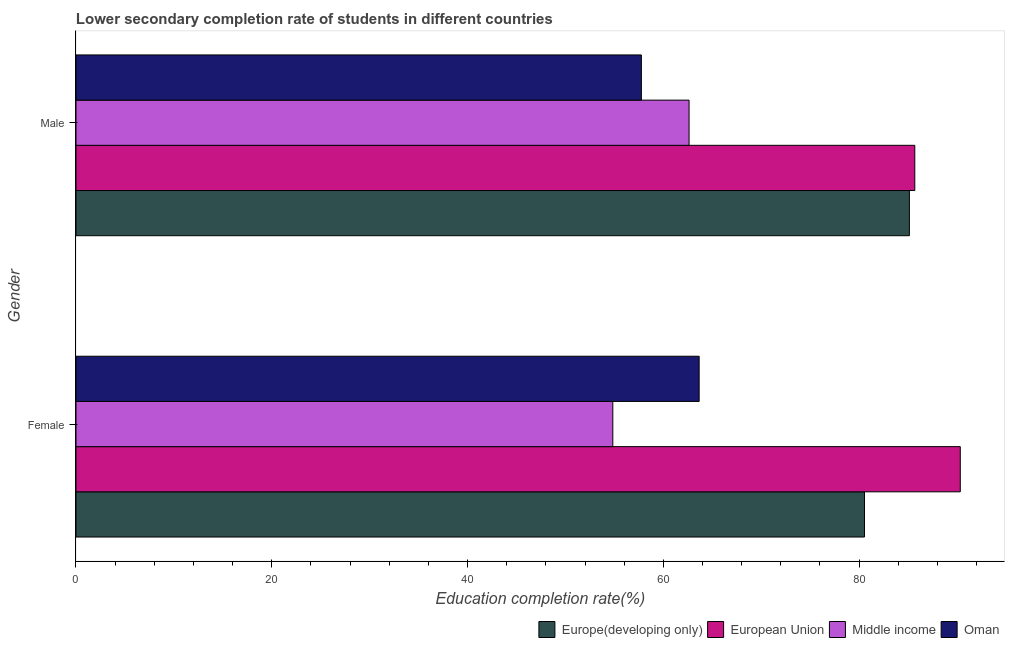How many different coloured bars are there?
Keep it short and to the point. 4. How many groups of bars are there?
Make the answer very short. 2. How many bars are there on the 2nd tick from the bottom?
Provide a succinct answer. 4. What is the label of the 1st group of bars from the top?
Provide a short and direct response. Male. What is the education completion rate of male students in Oman?
Your response must be concise. 57.75. Across all countries, what is the maximum education completion rate of female students?
Provide a short and direct response. 90.33. Across all countries, what is the minimum education completion rate of female students?
Offer a terse response. 54.84. In which country was the education completion rate of male students minimum?
Make the answer very short. Oman. What is the total education completion rate of female students in the graph?
Offer a terse response. 289.37. What is the difference between the education completion rate of female students in European Union and that in Europe(developing only)?
Provide a succinct answer. 9.79. What is the difference between the education completion rate of female students in Middle income and the education completion rate of male students in Oman?
Your answer should be compact. -2.92. What is the average education completion rate of male students per country?
Give a very brief answer. 72.8. What is the difference between the education completion rate of female students and education completion rate of male students in Middle income?
Your answer should be compact. -7.79. In how many countries, is the education completion rate of female students greater than 80 %?
Your answer should be compact. 2. What is the ratio of the education completion rate of female students in Oman to that in Middle income?
Your answer should be very brief. 1.16. What does the 4th bar from the top in Female represents?
Make the answer very short. Europe(developing only). What does the 2nd bar from the bottom in Female represents?
Provide a short and direct response. European Union. How many legend labels are there?
Ensure brevity in your answer.  4. How are the legend labels stacked?
Keep it short and to the point. Horizontal. What is the title of the graph?
Make the answer very short. Lower secondary completion rate of students in different countries. Does "Suriname" appear as one of the legend labels in the graph?
Keep it short and to the point. No. What is the label or title of the X-axis?
Ensure brevity in your answer.  Education completion rate(%). What is the Education completion rate(%) in Europe(developing only) in Female?
Keep it short and to the point. 80.55. What is the Education completion rate(%) of European Union in Female?
Offer a very short reply. 90.33. What is the Education completion rate(%) in Middle income in Female?
Your answer should be compact. 54.84. What is the Education completion rate(%) in Oman in Female?
Offer a terse response. 63.66. What is the Education completion rate(%) of Europe(developing only) in Male?
Offer a very short reply. 85.13. What is the Education completion rate(%) in European Union in Male?
Your answer should be very brief. 85.69. What is the Education completion rate(%) of Middle income in Male?
Provide a short and direct response. 62.63. What is the Education completion rate(%) of Oman in Male?
Give a very brief answer. 57.75. Across all Gender, what is the maximum Education completion rate(%) in Europe(developing only)?
Your answer should be compact. 85.13. Across all Gender, what is the maximum Education completion rate(%) of European Union?
Provide a succinct answer. 90.33. Across all Gender, what is the maximum Education completion rate(%) of Middle income?
Ensure brevity in your answer.  62.63. Across all Gender, what is the maximum Education completion rate(%) in Oman?
Your answer should be compact. 63.66. Across all Gender, what is the minimum Education completion rate(%) in Europe(developing only)?
Offer a terse response. 80.55. Across all Gender, what is the minimum Education completion rate(%) in European Union?
Make the answer very short. 85.69. Across all Gender, what is the minimum Education completion rate(%) of Middle income?
Offer a very short reply. 54.84. Across all Gender, what is the minimum Education completion rate(%) in Oman?
Your answer should be compact. 57.75. What is the total Education completion rate(%) in Europe(developing only) in the graph?
Provide a succinct answer. 165.68. What is the total Education completion rate(%) in European Union in the graph?
Offer a terse response. 176.02. What is the total Education completion rate(%) in Middle income in the graph?
Make the answer very short. 117.47. What is the total Education completion rate(%) of Oman in the graph?
Your answer should be compact. 121.41. What is the difference between the Education completion rate(%) in Europe(developing only) in Female and that in Male?
Give a very brief answer. -4.59. What is the difference between the Education completion rate(%) of European Union in Female and that in Male?
Provide a short and direct response. 4.65. What is the difference between the Education completion rate(%) of Middle income in Female and that in Male?
Ensure brevity in your answer.  -7.79. What is the difference between the Education completion rate(%) in Oman in Female and that in Male?
Your response must be concise. 5.9. What is the difference between the Education completion rate(%) in Europe(developing only) in Female and the Education completion rate(%) in European Union in Male?
Keep it short and to the point. -5.14. What is the difference between the Education completion rate(%) of Europe(developing only) in Female and the Education completion rate(%) of Middle income in Male?
Your response must be concise. 17.92. What is the difference between the Education completion rate(%) in Europe(developing only) in Female and the Education completion rate(%) in Oman in Male?
Give a very brief answer. 22.79. What is the difference between the Education completion rate(%) in European Union in Female and the Education completion rate(%) in Middle income in Male?
Your response must be concise. 27.7. What is the difference between the Education completion rate(%) in European Union in Female and the Education completion rate(%) in Oman in Male?
Make the answer very short. 32.58. What is the difference between the Education completion rate(%) of Middle income in Female and the Education completion rate(%) of Oman in Male?
Provide a succinct answer. -2.92. What is the average Education completion rate(%) of Europe(developing only) per Gender?
Give a very brief answer. 82.84. What is the average Education completion rate(%) of European Union per Gender?
Give a very brief answer. 88.01. What is the average Education completion rate(%) of Middle income per Gender?
Provide a succinct answer. 58.73. What is the average Education completion rate(%) of Oman per Gender?
Provide a short and direct response. 60.71. What is the difference between the Education completion rate(%) of Europe(developing only) and Education completion rate(%) of European Union in Female?
Offer a terse response. -9.79. What is the difference between the Education completion rate(%) of Europe(developing only) and Education completion rate(%) of Middle income in Female?
Ensure brevity in your answer.  25.71. What is the difference between the Education completion rate(%) of Europe(developing only) and Education completion rate(%) of Oman in Female?
Provide a succinct answer. 16.89. What is the difference between the Education completion rate(%) in European Union and Education completion rate(%) in Middle income in Female?
Make the answer very short. 35.49. What is the difference between the Education completion rate(%) in European Union and Education completion rate(%) in Oman in Female?
Your answer should be very brief. 26.67. What is the difference between the Education completion rate(%) in Middle income and Education completion rate(%) in Oman in Female?
Your answer should be very brief. -8.82. What is the difference between the Education completion rate(%) in Europe(developing only) and Education completion rate(%) in European Union in Male?
Your response must be concise. -0.55. What is the difference between the Education completion rate(%) in Europe(developing only) and Education completion rate(%) in Middle income in Male?
Offer a very short reply. 22.5. What is the difference between the Education completion rate(%) of Europe(developing only) and Education completion rate(%) of Oman in Male?
Make the answer very short. 27.38. What is the difference between the Education completion rate(%) in European Union and Education completion rate(%) in Middle income in Male?
Your answer should be very brief. 23.06. What is the difference between the Education completion rate(%) in European Union and Education completion rate(%) in Oman in Male?
Offer a very short reply. 27.93. What is the difference between the Education completion rate(%) of Middle income and Education completion rate(%) of Oman in Male?
Your response must be concise. 4.87. What is the ratio of the Education completion rate(%) of Europe(developing only) in Female to that in Male?
Offer a very short reply. 0.95. What is the ratio of the Education completion rate(%) of European Union in Female to that in Male?
Provide a short and direct response. 1.05. What is the ratio of the Education completion rate(%) of Middle income in Female to that in Male?
Offer a very short reply. 0.88. What is the ratio of the Education completion rate(%) in Oman in Female to that in Male?
Ensure brevity in your answer.  1.1. What is the difference between the highest and the second highest Education completion rate(%) of Europe(developing only)?
Keep it short and to the point. 4.59. What is the difference between the highest and the second highest Education completion rate(%) of European Union?
Provide a short and direct response. 4.65. What is the difference between the highest and the second highest Education completion rate(%) in Middle income?
Ensure brevity in your answer.  7.79. What is the difference between the highest and the second highest Education completion rate(%) of Oman?
Offer a very short reply. 5.9. What is the difference between the highest and the lowest Education completion rate(%) in Europe(developing only)?
Provide a short and direct response. 4.59. What is the difference between the highest and the lowest Education completion rate(%) in European Union?
Make the answer very short. 4.65. What is the difference between the highest and the lowest Education completion rate(%) of Middle income?
Make the answer very short. 7.79. What is the difference between the highest and the lowest Education completion rate(%) of Oman?
Your response must be concise. 5.9. 